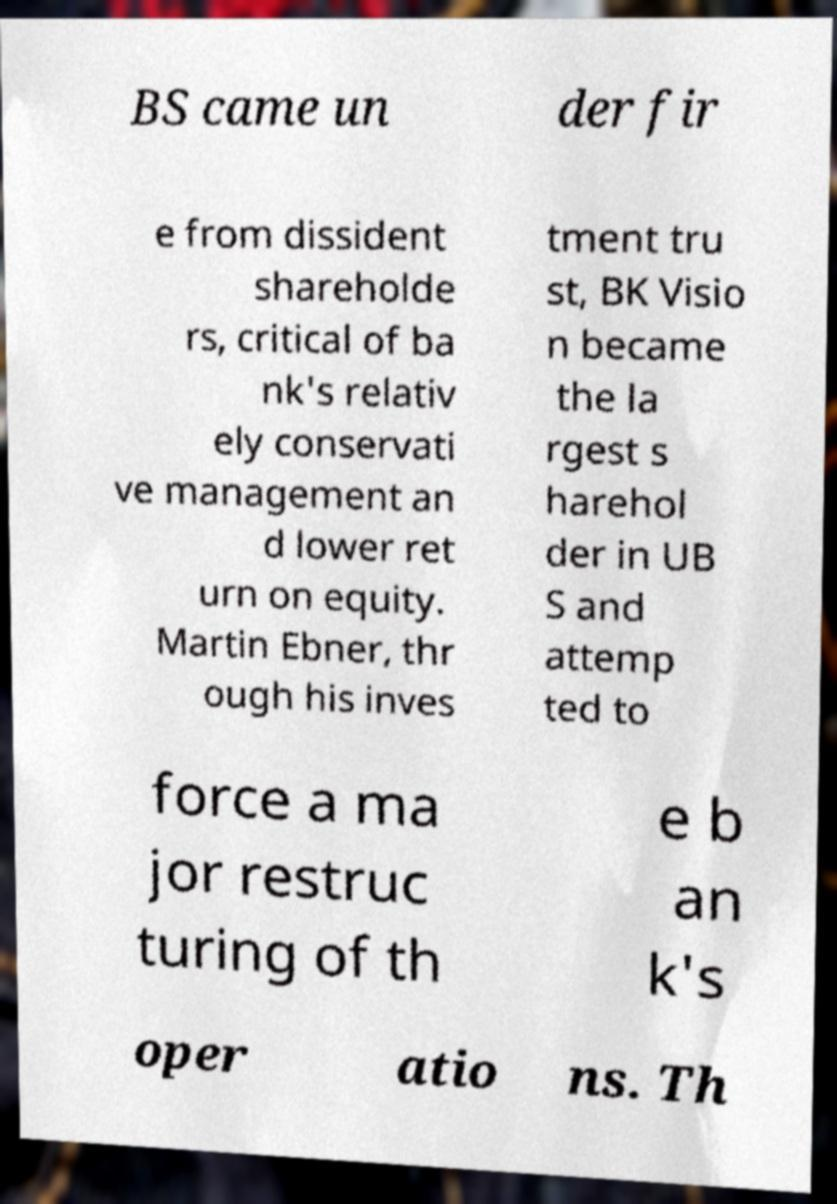Could you extract and type out the text from this image? BS came un der fir e from dissident shareholde rs, critical of ba nk's relativ ely conservati ve management an d lower ret urn on equity. Martin Ebner, thr ough his inves tment tru st, BK Visio n became the la rgest s harehol der in UB S and attemp ted to force a ma jor restruc turing of th e b an k's oper atio ns. Th 